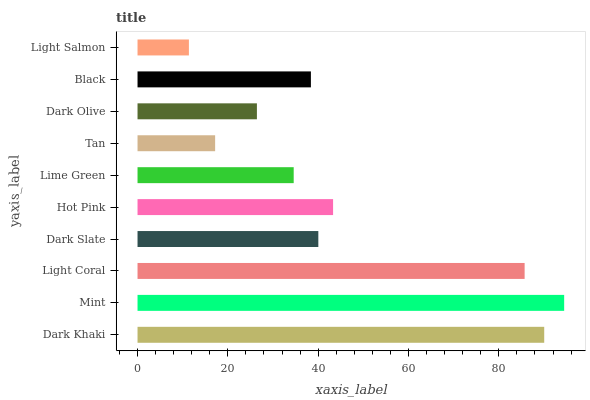Is Light Salmon the minimum?
Answer yes or no. Yes. Is Mint the maximum?
Answer yes or no. Yes. Is Light Coral the minimum?
Answer yes or no. No. Is Light Coral the maximum?
Answer yes or no. No. Is Mint greater than Light Coral?
Answer yes or no. Yes. Is Light Coral less than Mint?
Answer yes or no. Yes. Is Light Coral greater than Mint?
Answer yes or no. No. Is Mint less than Light Coral?
Answer yes or no. No. Is Dark Slate the high median?
Answer yes or no. Yes. Is Black the low median?
Answer yes or no. Yes. Is Dark Olive the high median?
Answer yes or no. No. Is Dark Olive the low median?
Answer yes or no. No. 